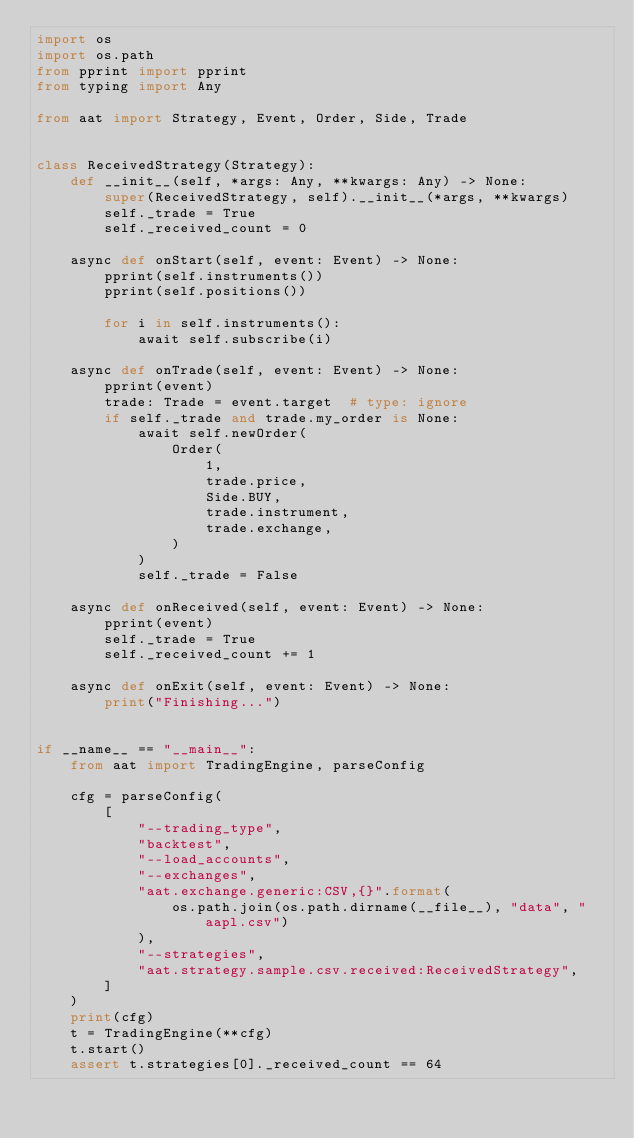Convert code to text. <code><loc_0><loc_0><loc_500><loc_500><_Python_>import os
import os.path
from pprint import pprint
from typing import Any

from aat import Strategy, Event, Order, Side, Trade


class ReceivedStrategy(Strategy):
    def __init__(self, *args: Any, **kwargs: Any) -> None:
        super(ReceivedStrategy, self).__init__(*args, **kwargs)
        self._trade = True
        self._received_count = 0

    async def onStart(self, event: Event) -> None:
        pprint(self.instruments())
        pprint(self.positions())

        for i in self.instruments():
            await self.subscribe(i)

    async def onTrade(self, event: Event) -> None:
        pprint(event)
        trade: Trade = event.target  # type: ignore
        if self._trade and trade.my_order is None:
            await self.newOrder(
                Order(
                    1,
                    trade.price,
                    Side.BUY,
                    trade.instrument,
                    trade.exchange,
                )
            )
            self._trade = False

    async def onReceived(self, event: Event) -> None:
        pprint(event)
        self._trade = True
        self._received_count += 1

    async def onExit(self, event: Event) -> None:
        print("Finishing...")


if __name__ == "__main__":
    from aat import TradingEngine, parseConfig

    cfg = parseConfig(
        [
            "--trading_type",
            "backtest",
            "--load_accounts",
            "--exchanges",
            "aat.exchange.generic:CSV,{}".format(
                os.path.join(os.path.dirname(__file__), "data", "aapl.csv")
            ),
            "--strategies",
            "aat.strategy.sample.csv.received:ReceivedStrategy",
        ]
    )
    print(cfg)
    t = TradingEngine(**cfg)
    t.start()
    assert t.strategies[0]._received_count == 64
</code> 